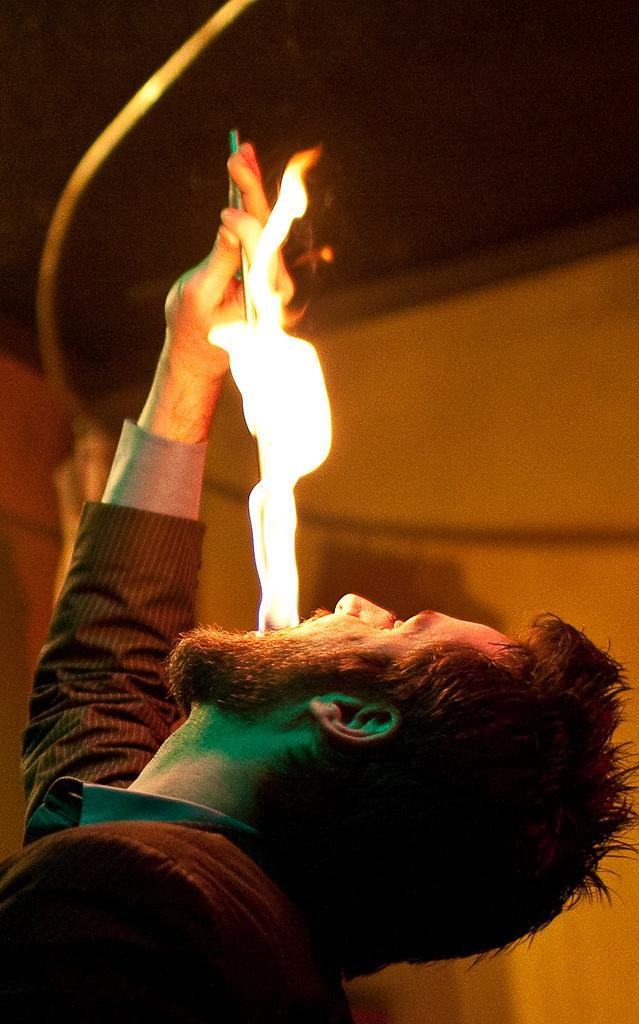What is the main subject of the image? The main subject of the image is a man. What is the man doing in the image? The man is having fire coming from his mouth. Is the man making a payment for the fire coming from his mouth in the image? There is no indication in the image that the man is making a payment for the fire coming from his mouth. 